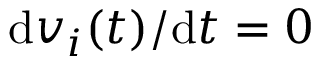Convert formula to latex. <formula><loc_0><loc_0><loc_500><loc_500>d v _ { i } ( t ) / d t = 0</formula> 